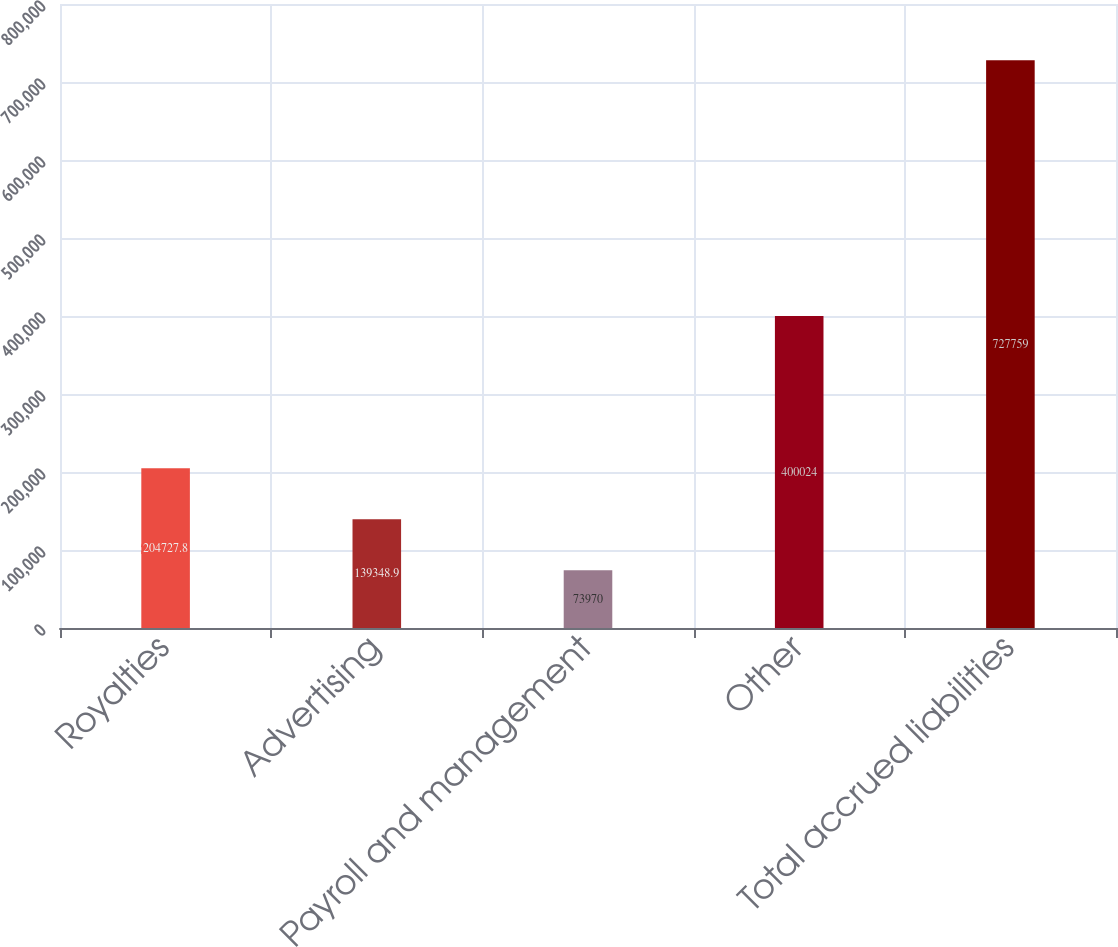<chart> <loc_0><loc_0><loc_500><loc_500><bar_chart><fcel>Royalties<fcel>Advertising<fcel>Payroll and management<fcel>Other<fcel>Total accrued liabilities<nl><fcel>204728<fcel>139349<fcel>73970<fcel>400024<fcel>727759<nl></chart> 